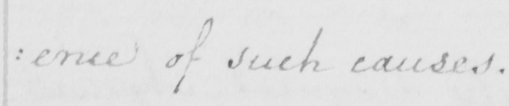What does this handwritten line say? : ence of such causes . 